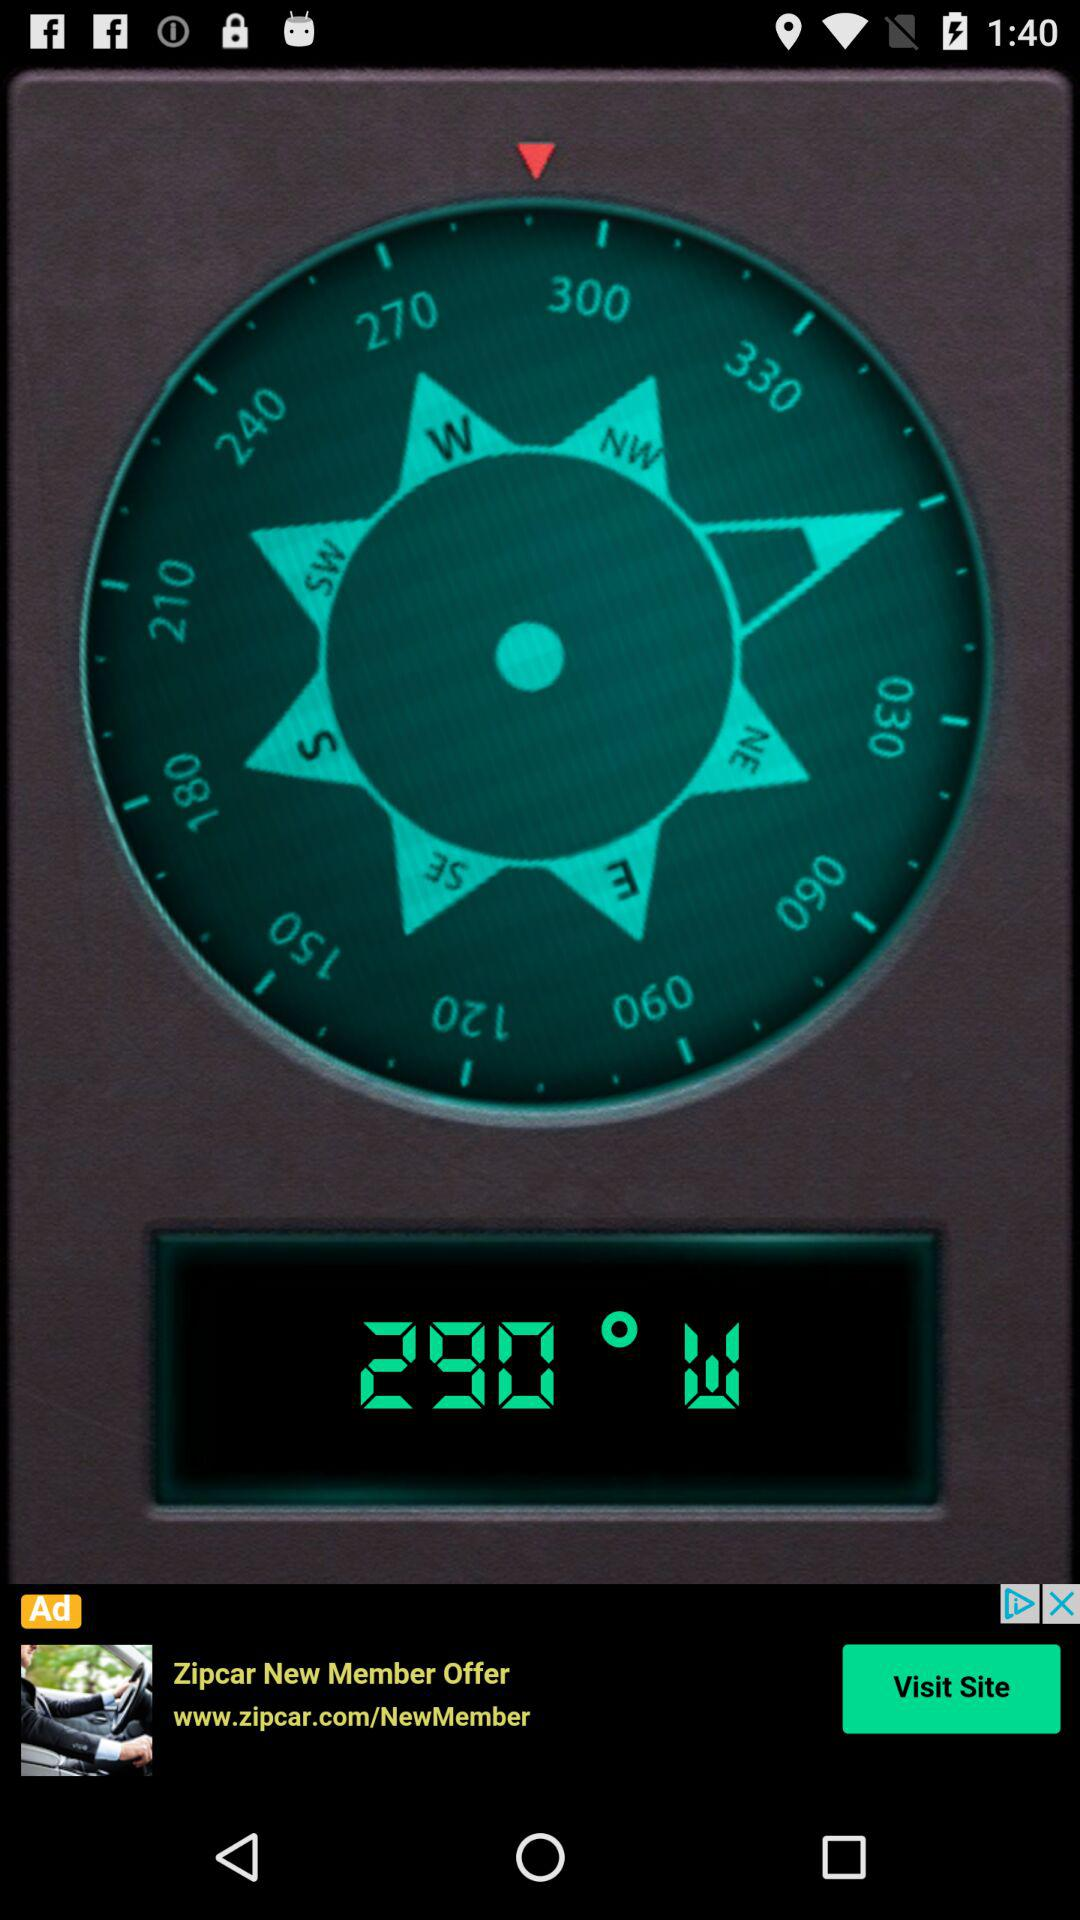What is the name of the application?
When the provided information is insufficient, respond with <no answer>. <no answer> 